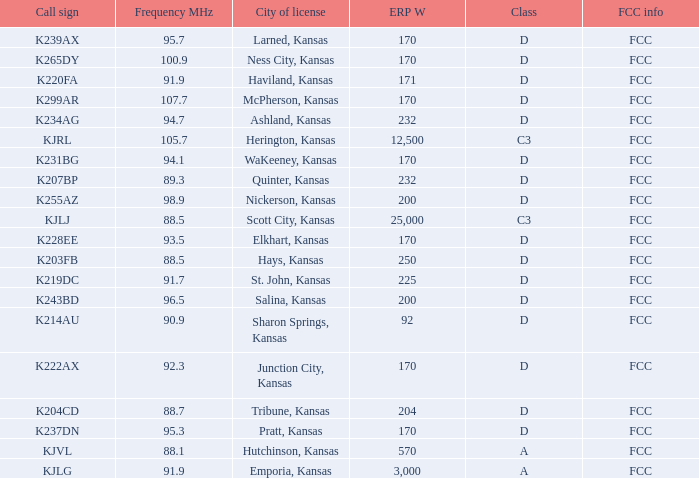ERP W that has a Class of d, and a Call sign of k299ar is what total number? 1.0. 